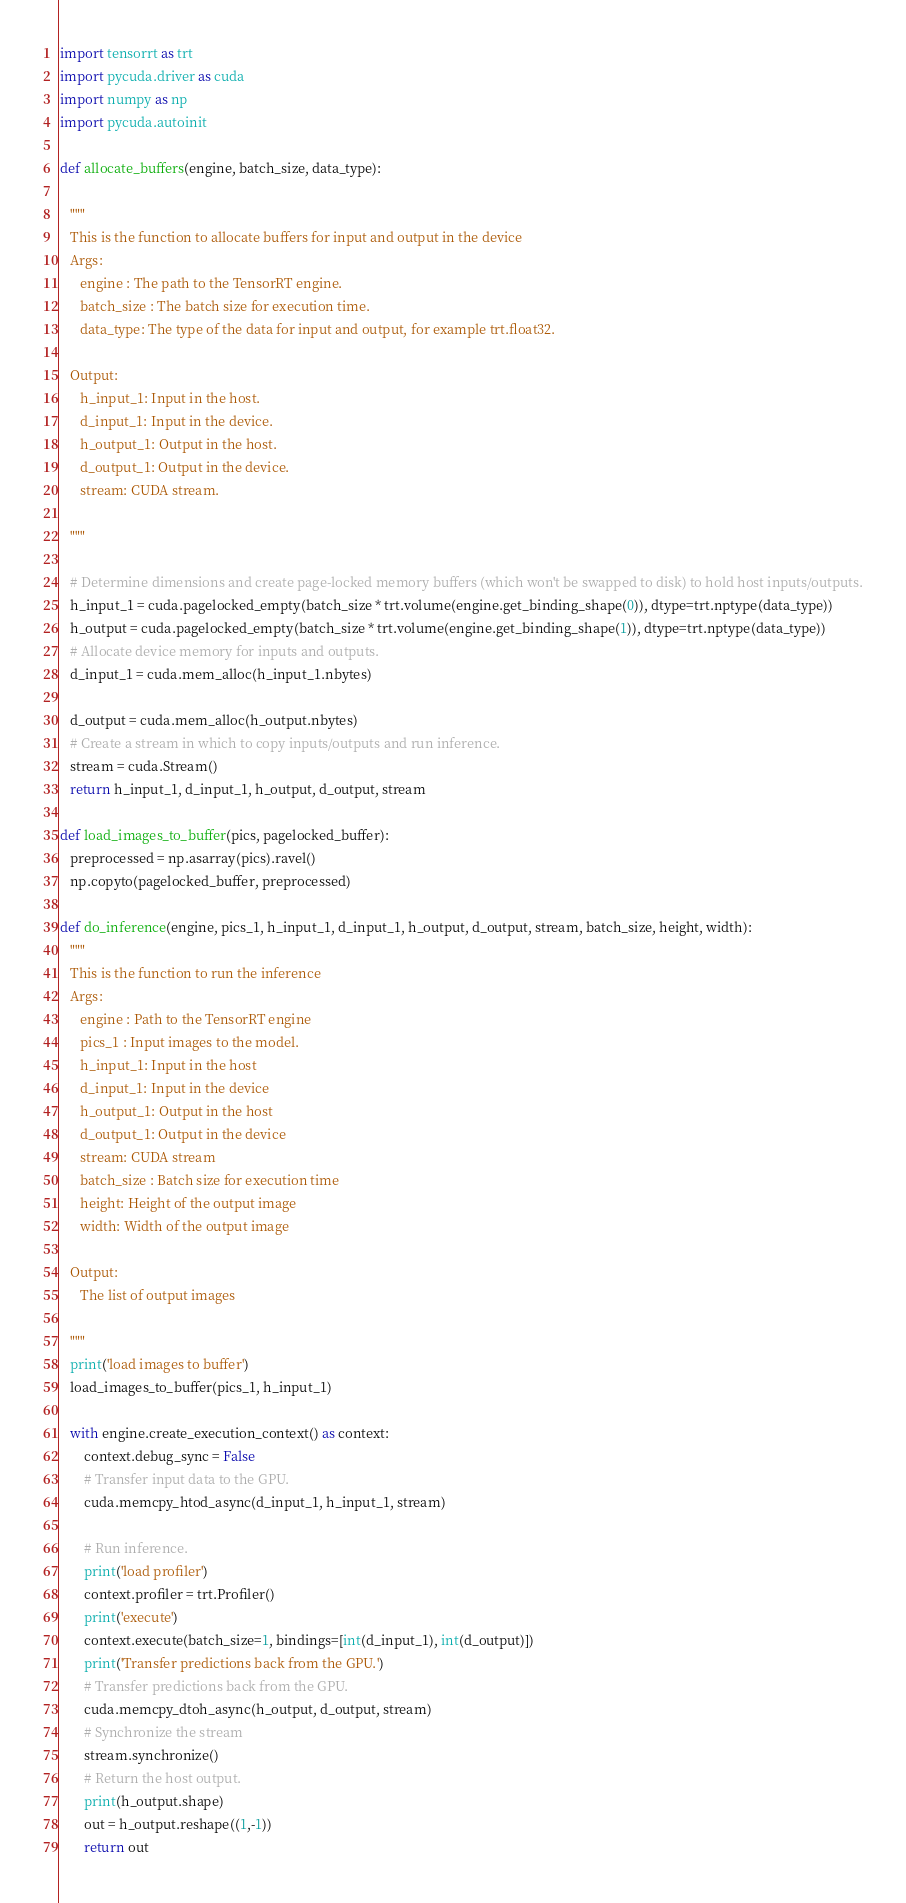<code> <loc_0><loc_0><loc_500><loc_500><_Python_>import tensorrt as trt
import pycuda.driver as cuda
import numpy as np
import pycuda.autoinit 

def allocate_buffers(engine, batch_size, data_type):

   """
   This is the function to allocate buffers for input and output in the device
   Args:
      engine : The path to the TensorRT engine. 
      batch_size : The batch size for execution time.
      data_type: The type of the data for input and output, for example trt.float32. 
   
   Output:
      h_input_1: Input in the host.
      d_input_1: Input in the device. 
      h_output_1: Output in the host. 
      d_output_1: Output in the device. 
      stream: CUDA stream.

   """

   # Determine dimensions and create page-locked memory buffers (which won't be swapped to disk) to hold host inputs/outputs.
   h_input_1 = cuda.pagelocked_empty(batch_size * trt.volume(engine.get_binding_shape(0)), dtype=trt.nptype(data_type))
   h_output = cuda.pagelocked_empty(batch_size * trt.volume(engine.get_binding_shape(1)), dtype=trt.nptype(data_type))
   # Allocate device memory for inputs and outputs.
   d_input_1 = cuda.mem_alloc(h_input_1.nbytes)

   d_output = cuda.mem_alloc(h_output.nbytes)
   # Create a stream in which to copy inputs/outputs and run inference.
   stream = cuda.Stream()
   return h_input_1, d_input_1, h_output, d_output, stream 

def load_images_to_buffer(pics, pagelocked_buffer):
   preprocessed = np.asarray(pics).ravel()
   np.copyto(pagelocked_buffer, preprocessed) 

def do_inference(engine, pics_1, h_input_1, d_input_1, h_output, d_output, stream, batch_size, height, width):
   """
   This is the function to run the inference
   Args:
      engine : Path to the TensorRT engine 
      pics_1 : Input images to the model.  
      h_input_1: Input in the host         
      d_input_1: Input in the device 
      h_output_1: Output in the host 
      d_output_1: Output in the device 
      stream: CUDA stream
      batch_size : Batch size for execution time
      height: Height of the output image
      width: Width of the output image
   
   Output:
      The list of output images

   """
   print('load images to buffer')
   load_images_to_buffer(pics_1, h_input_1)

   with engine.create_execution_context() as context:
       context.debug_sync = False
       # Transfer input data to the GPU.
       cuda.memcpy_htod_async(d_input_1, h_input_1, stream)

       # Run inference.
       print('load profiler')
       context.profiler = trt.Profiler()
       print('execute')
       context.execute(batch_size=1, bindings=[int(d_input_1), int(d_output)])
       print('Transfer predictions back from the GPU.')
       # Transfer predictions back from the GPU.
       cuda.memcpy_dtoh_async(h_output, d_output, stream)
       # Synchronize the stream
       stream.synchronize()
       # Return the host output.
       print(h_output.shape)
       out = h_output.reshape((1,-1))
       return out 
</code> 